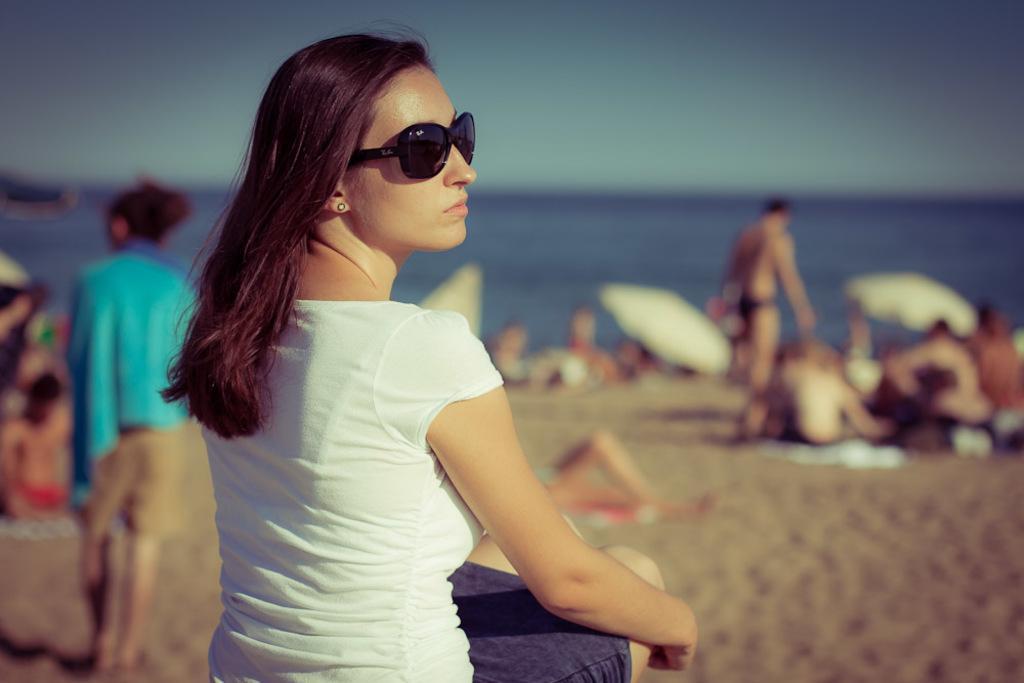Could you give a brief overview of what you see in this image? In this image there is one women sitting in middle of this image is wearing white color t shirt and wearing black color goggles and there is one women at left side of this image and there are some persons at right side of this image and there is a water in middle of this image and there is a sky at top of this image. 